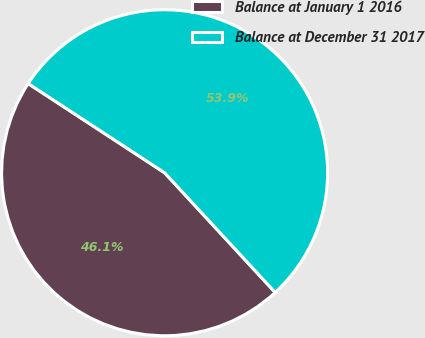Convert chart. <chart><loc_0><loc_0><loc_500><loc_500><pie_chart><fcel>Balance at January 1 2016<fcel>Balance at December 31 2017<nl><fcel>46.09%<fcel>53.91%<nl></chart> 